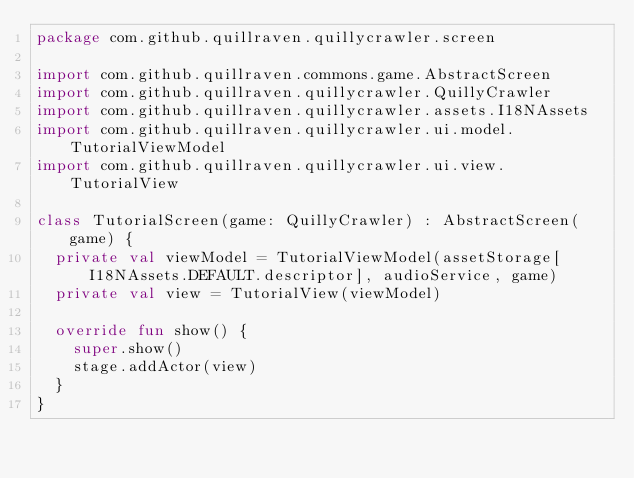Convert code to text. <code><loc_0><loc_0><loc_500><loc_500><_Kotlin_>package com.github.quillraven.quillycrawler.screen

import com.github.quillraven.commons.game.AbstractScreen
import com.github.quillraven.quillycrawler.QuillyCrawler
import com.github.quillraven.quillycrawler.assets.I18NAssets
import com.github.quillraven.quillycrawler.ui.model.TutorialViewModel
import com.github.quillraven.quillycrawler.ui.view.TutorialView

class TutorialScreen(game: QuillyCrawler) : AbstractScreen(game) {
  private val viewModel = TutorialViewModel(assetStorage[I18NAssets.DEFAULT.descriptor], audioService, game)
  private val view = TutorialView(viewModel)

  override fun show() {
    super.show()
    stage.addActor(view)
  }
}
</code> 